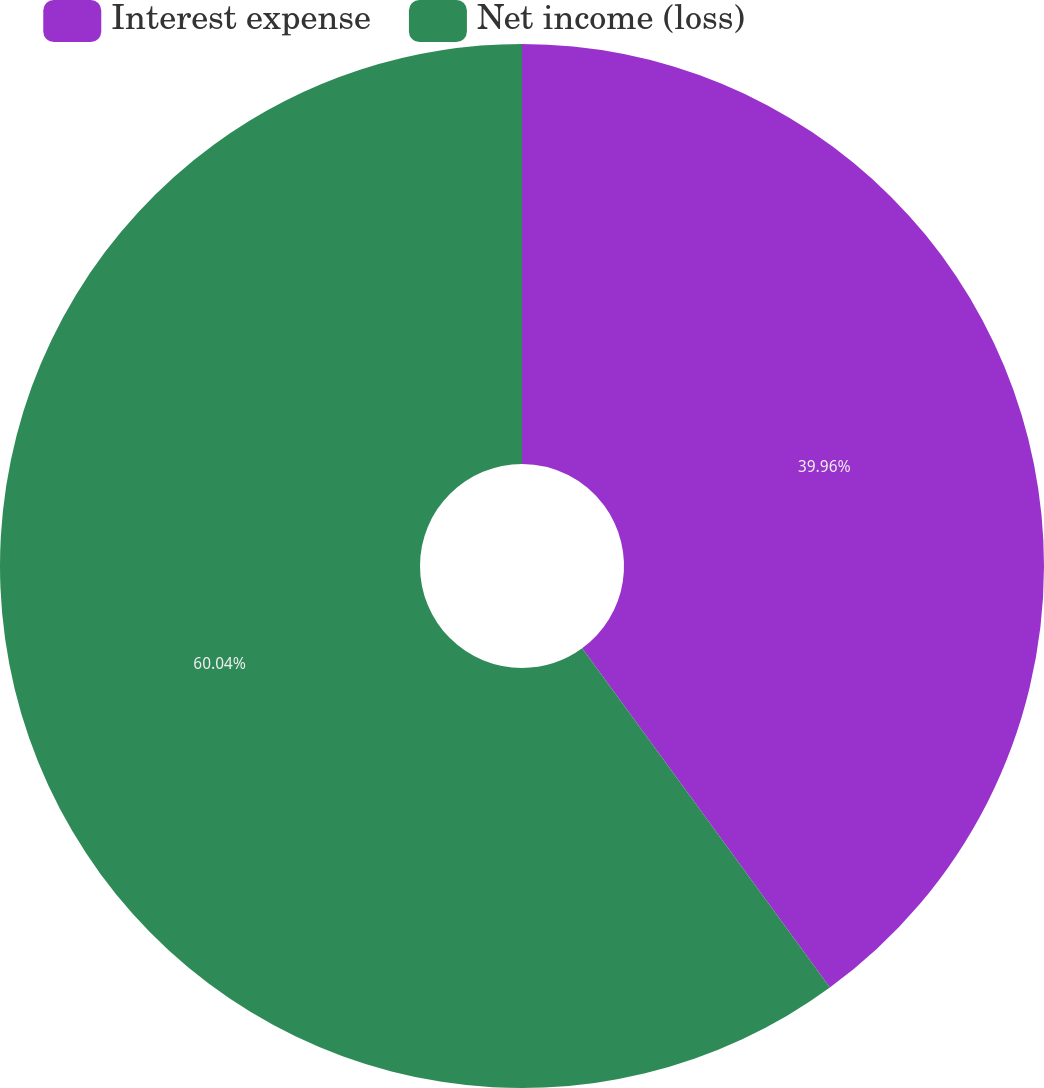Convert chart. <chart><loc_0><loc_0><loc_500><loc_500><pie_chart><fcel>Interest expense<fcel>Net income (loss)<nl><fcel>39.96%<fcel>60.04%<nl></chart> 